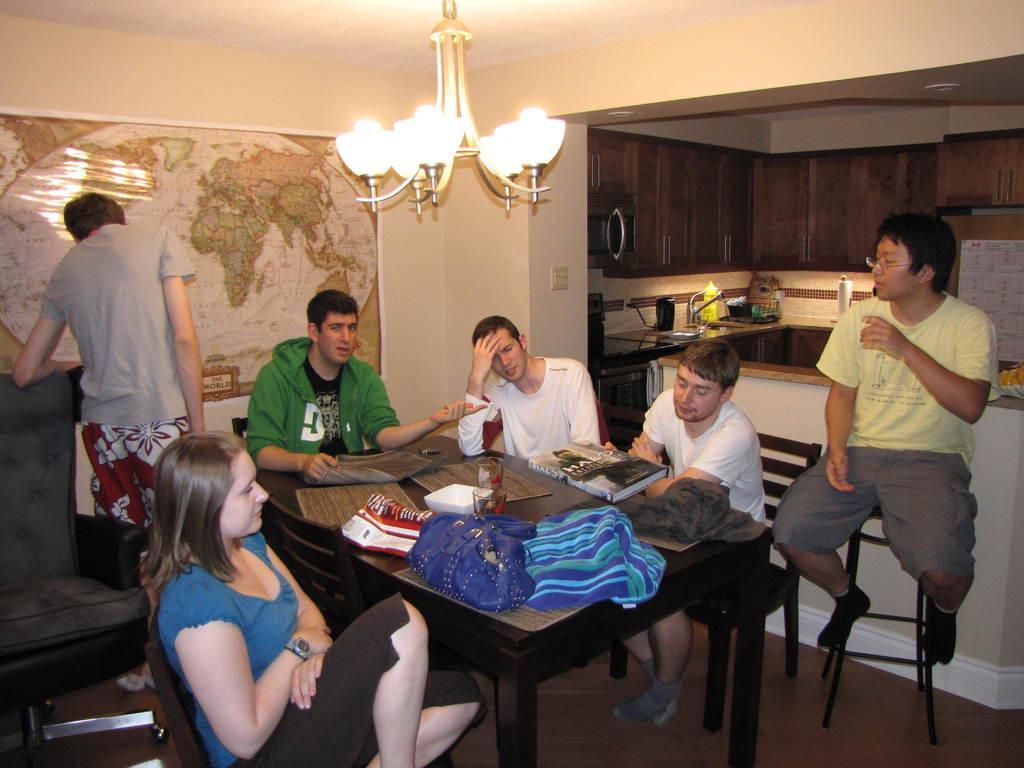Could you give a brief overview of what you see in this image? In this picture we can see a group of people some are sitting on chair and some are standing and in front of them there is table and on table we can see book, cloth, glass, plastic cover, paper and in background we can see wall, chandelier, flask, calendar. 